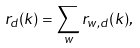<formula> <loc_0><loc_0><loc_500><loc_500>r _ { d } ( k ) = \sum _ { w } r _ { w , d } ( k ) ,</formula> 